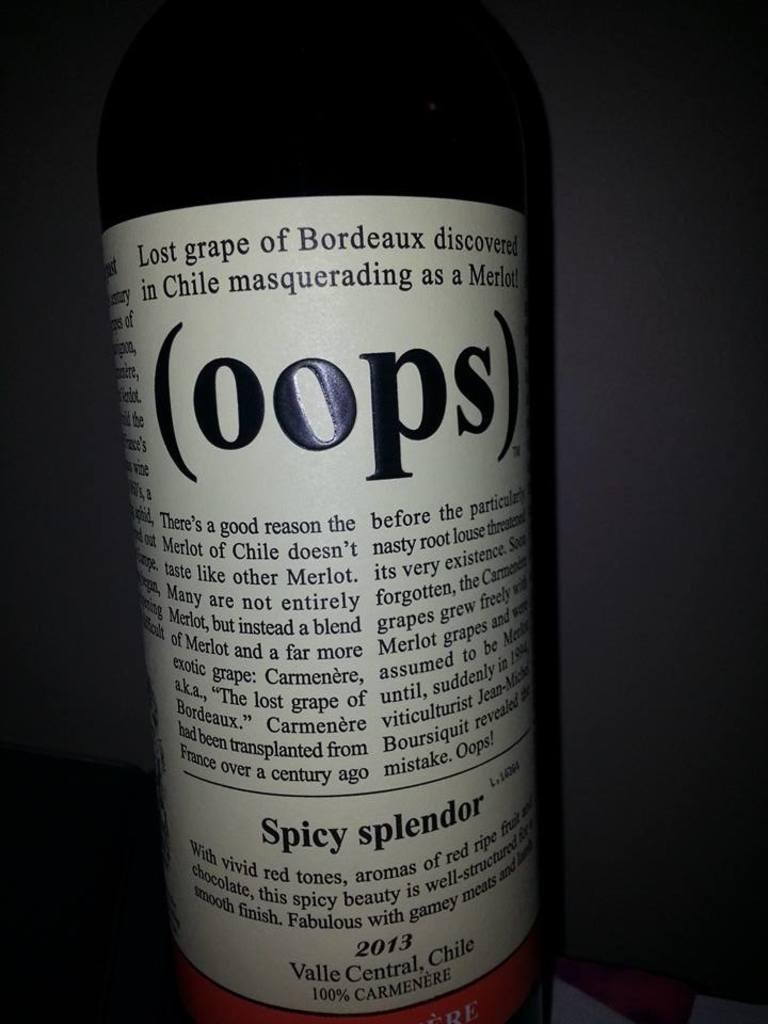What word is in parentheses on the lable?
Provide a succinct answer. Oops. What year is shown?
Your response must be concise. 2013. 